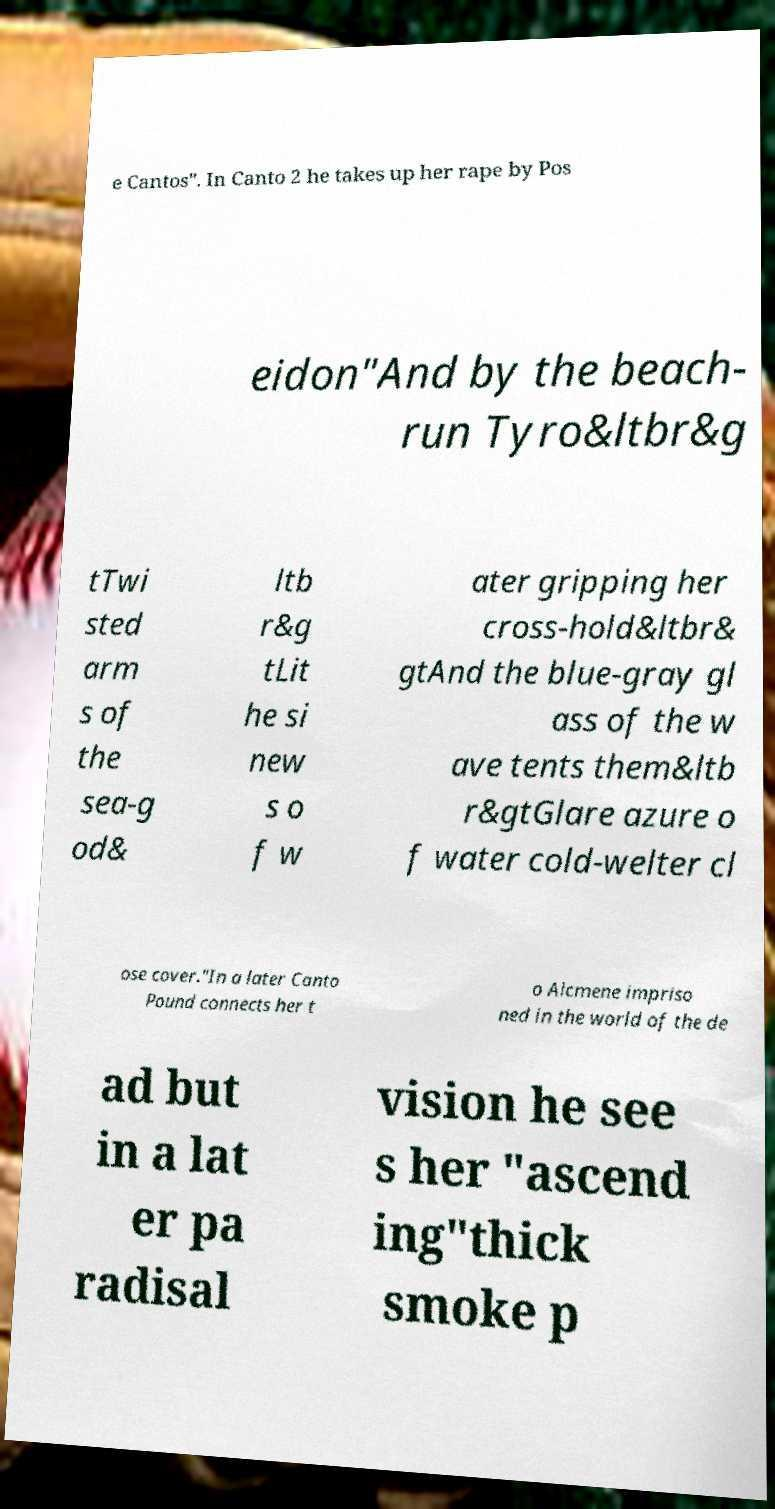Could you extract and type out the text from this image? e Cantos". In Canto 2 he takes up her rape by Pos eidon"And by the beach- run Tyro&ltbr&g tTwi sted arm s of the sea-g od& ltb r&g tLit he si new s o f w ater gripping her cross-hold&ltbr& gtAnd the blue-gray gl ass of the w ave tents them&ltb r&gtGlare azure o f water cold-welter cl ose cover."In a later Canto Pound connects her t o Alcmene impriso ned in the world of the de ad but in a lat er pa radisal vision he see s her "ascend ing"thick smoke p 